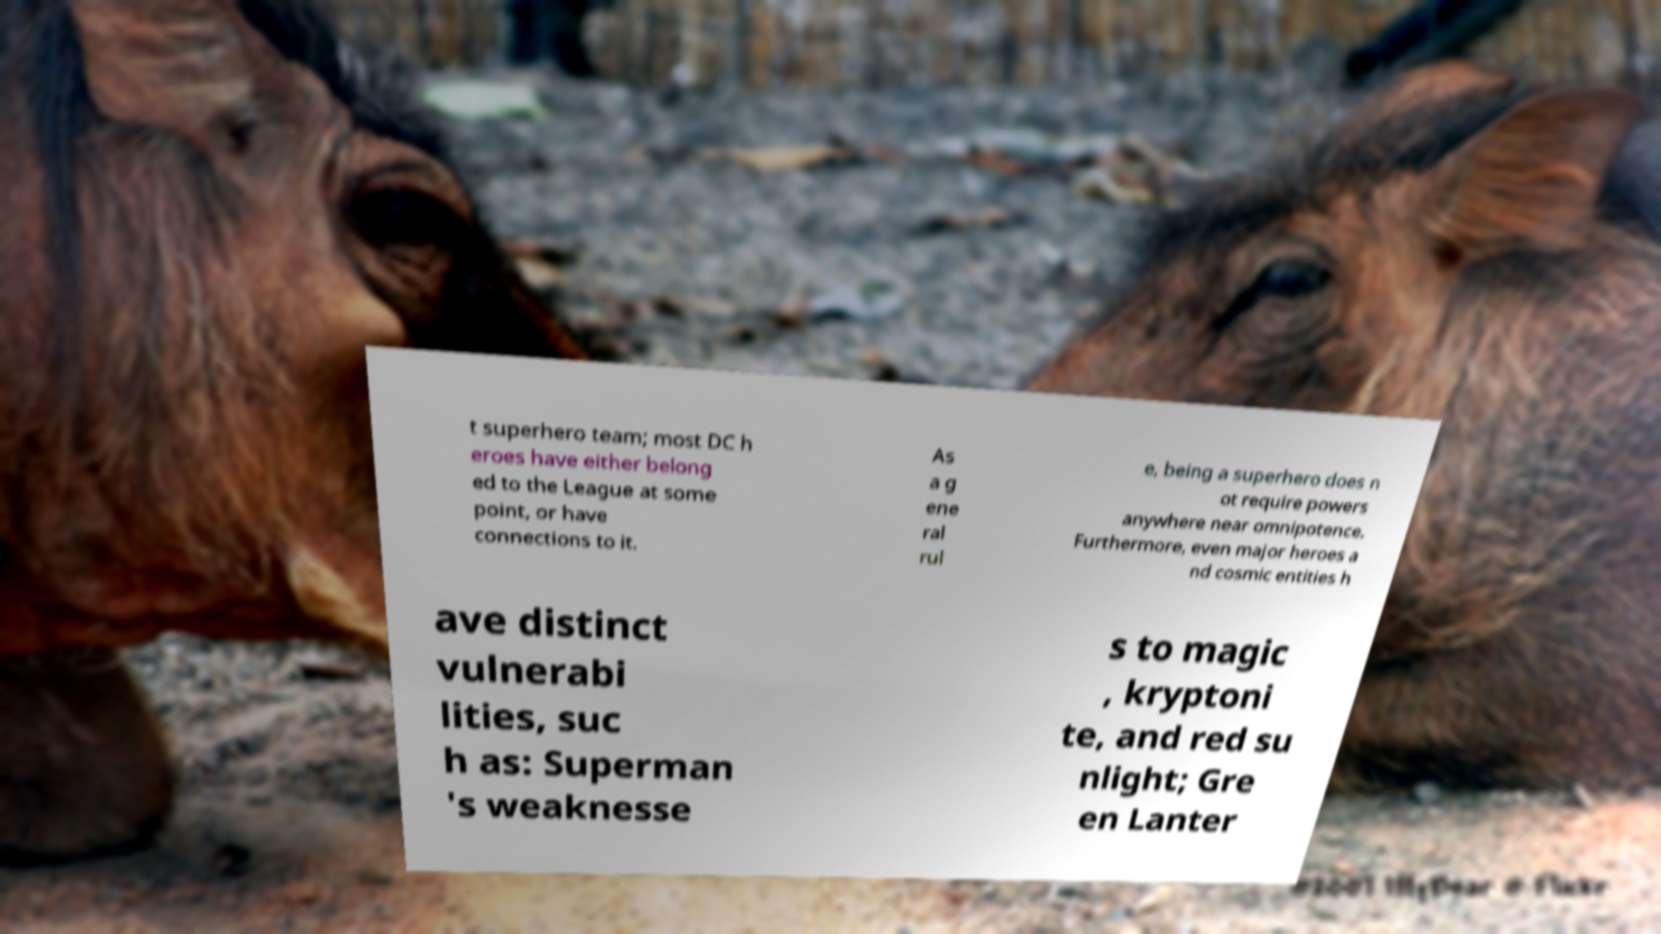Please read and relay the text visible in this image. What does it say? t superhero team; most DC h eroes have either belong ed to the League at some point, or have connections to it. As a g ene ral rul e, being a superhero does n ot require powers anywhere near omnipotence. Furthermore, even major heroes a nd cosmic entities h ave distinct vulnerabi lities, suc h as: Superman 's weaknesse s to magic , kryptoni te, and red su nlight; Gre en Lanter 